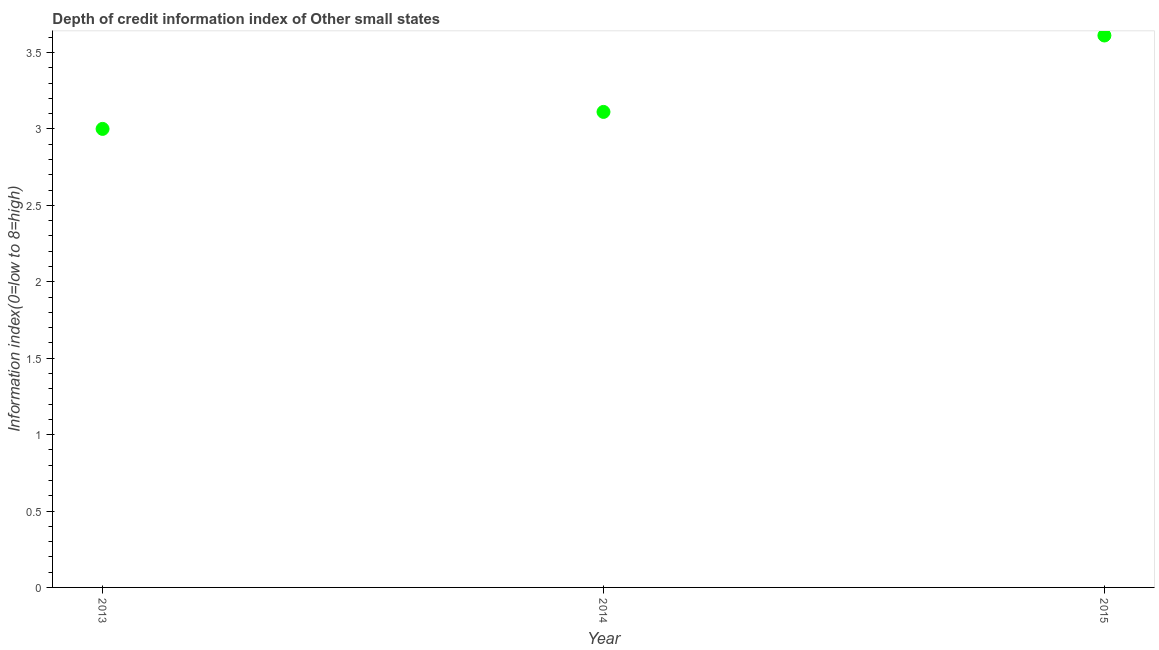What is the depth of credit information index in 2015?
Your response must be concise. 3.61. Across all years, what is the maximum depth of credit information index?
Ensure brevity in your answer.  3.61. Across all years, what is the minimum depth of credit information index?
Offer a very short reply. 3. In which year was the depth of credit information index maximum?
Your response must be concise. 2015. In which year was the depth of credit information index minimum?
Offer a very short reply. 2013. What is the sum of the depth of credit information index?
Provide a succinct answer. 9.72. What is the difference between the depth of credit information index in 2014 and 2015?
Provide a short and direct response. -0.5. What is the average depth of credit information index per year?
Make the answer very short. 3.24. What is the median depth of credit information index?
Make the answer very short. 3.11. Do a majority of the years between 2015 and 2013 (inclusive) have depth of credit information index greater than 3.4 ?
Keep it short and to the point. No. What is the ratio of the depth of credit information index in 2013 to that in 2014?
Your response must be concise. 0.96. Is the depth of credit information index in 2013 less than that in 2014?
Give a very brief answer. Yes. What is the difference between the highest and the second highest depth of credit information index?
Offer a very short reply. 0.5. Is the sum of the depth of credit information index in 2014 and 2015 greater than the maximum depth of credit information index across all years?
Your response must be concise. Yes. What is the difference between the highest and the lowest depth of credit information index?
Keep it short and to the point. 0.61. In how many years, is the depth of credit information index greater than the average depth of credit information index taken over all years?
Offer a terse response. 1. How many dotlines are there?
Keep it short and to the point. 1. What is the difference between two consecutive major ticks on the Y-axis?
Give a very brief answer. 0.5. Does the graph contain any zero values?
Keep it short and to the point. No. What is the title of the graph?
Offer a terse response. Depth of credit information index of Other small states. What is the label or title of the Y-axis?
Your answer should be very brief. Information index(0=low to 8=high). What is the Information index(0=low to 8=high) in 2014?
Ensure brevity in your answer.  3.11. What is the Information index(0=low to 8=high) in 2015?
Offer a very short reply. 3.61. What is the difference between the Information index(0=low to 8=high) in 2013 and 2014?
Your response must be concise. -0.11. What is the difference between the Information index(0=low to 8=high) in 2013 and 2015?
Ensure brevity in your answer.  -0.61. What is the difference between the Information index(0=low to 8=high) in 2014 and 2015?
Offer a very short reply. -0.5. What is the ratio of the Information index(0=low to 8=high) in 2013 to that in 2015?
Give a very brief answer. 0.83. What is the ratio of the Information index(0=low to 8=high) in 2014 to that in 2015?
Your answer should be compact. 0.86. 